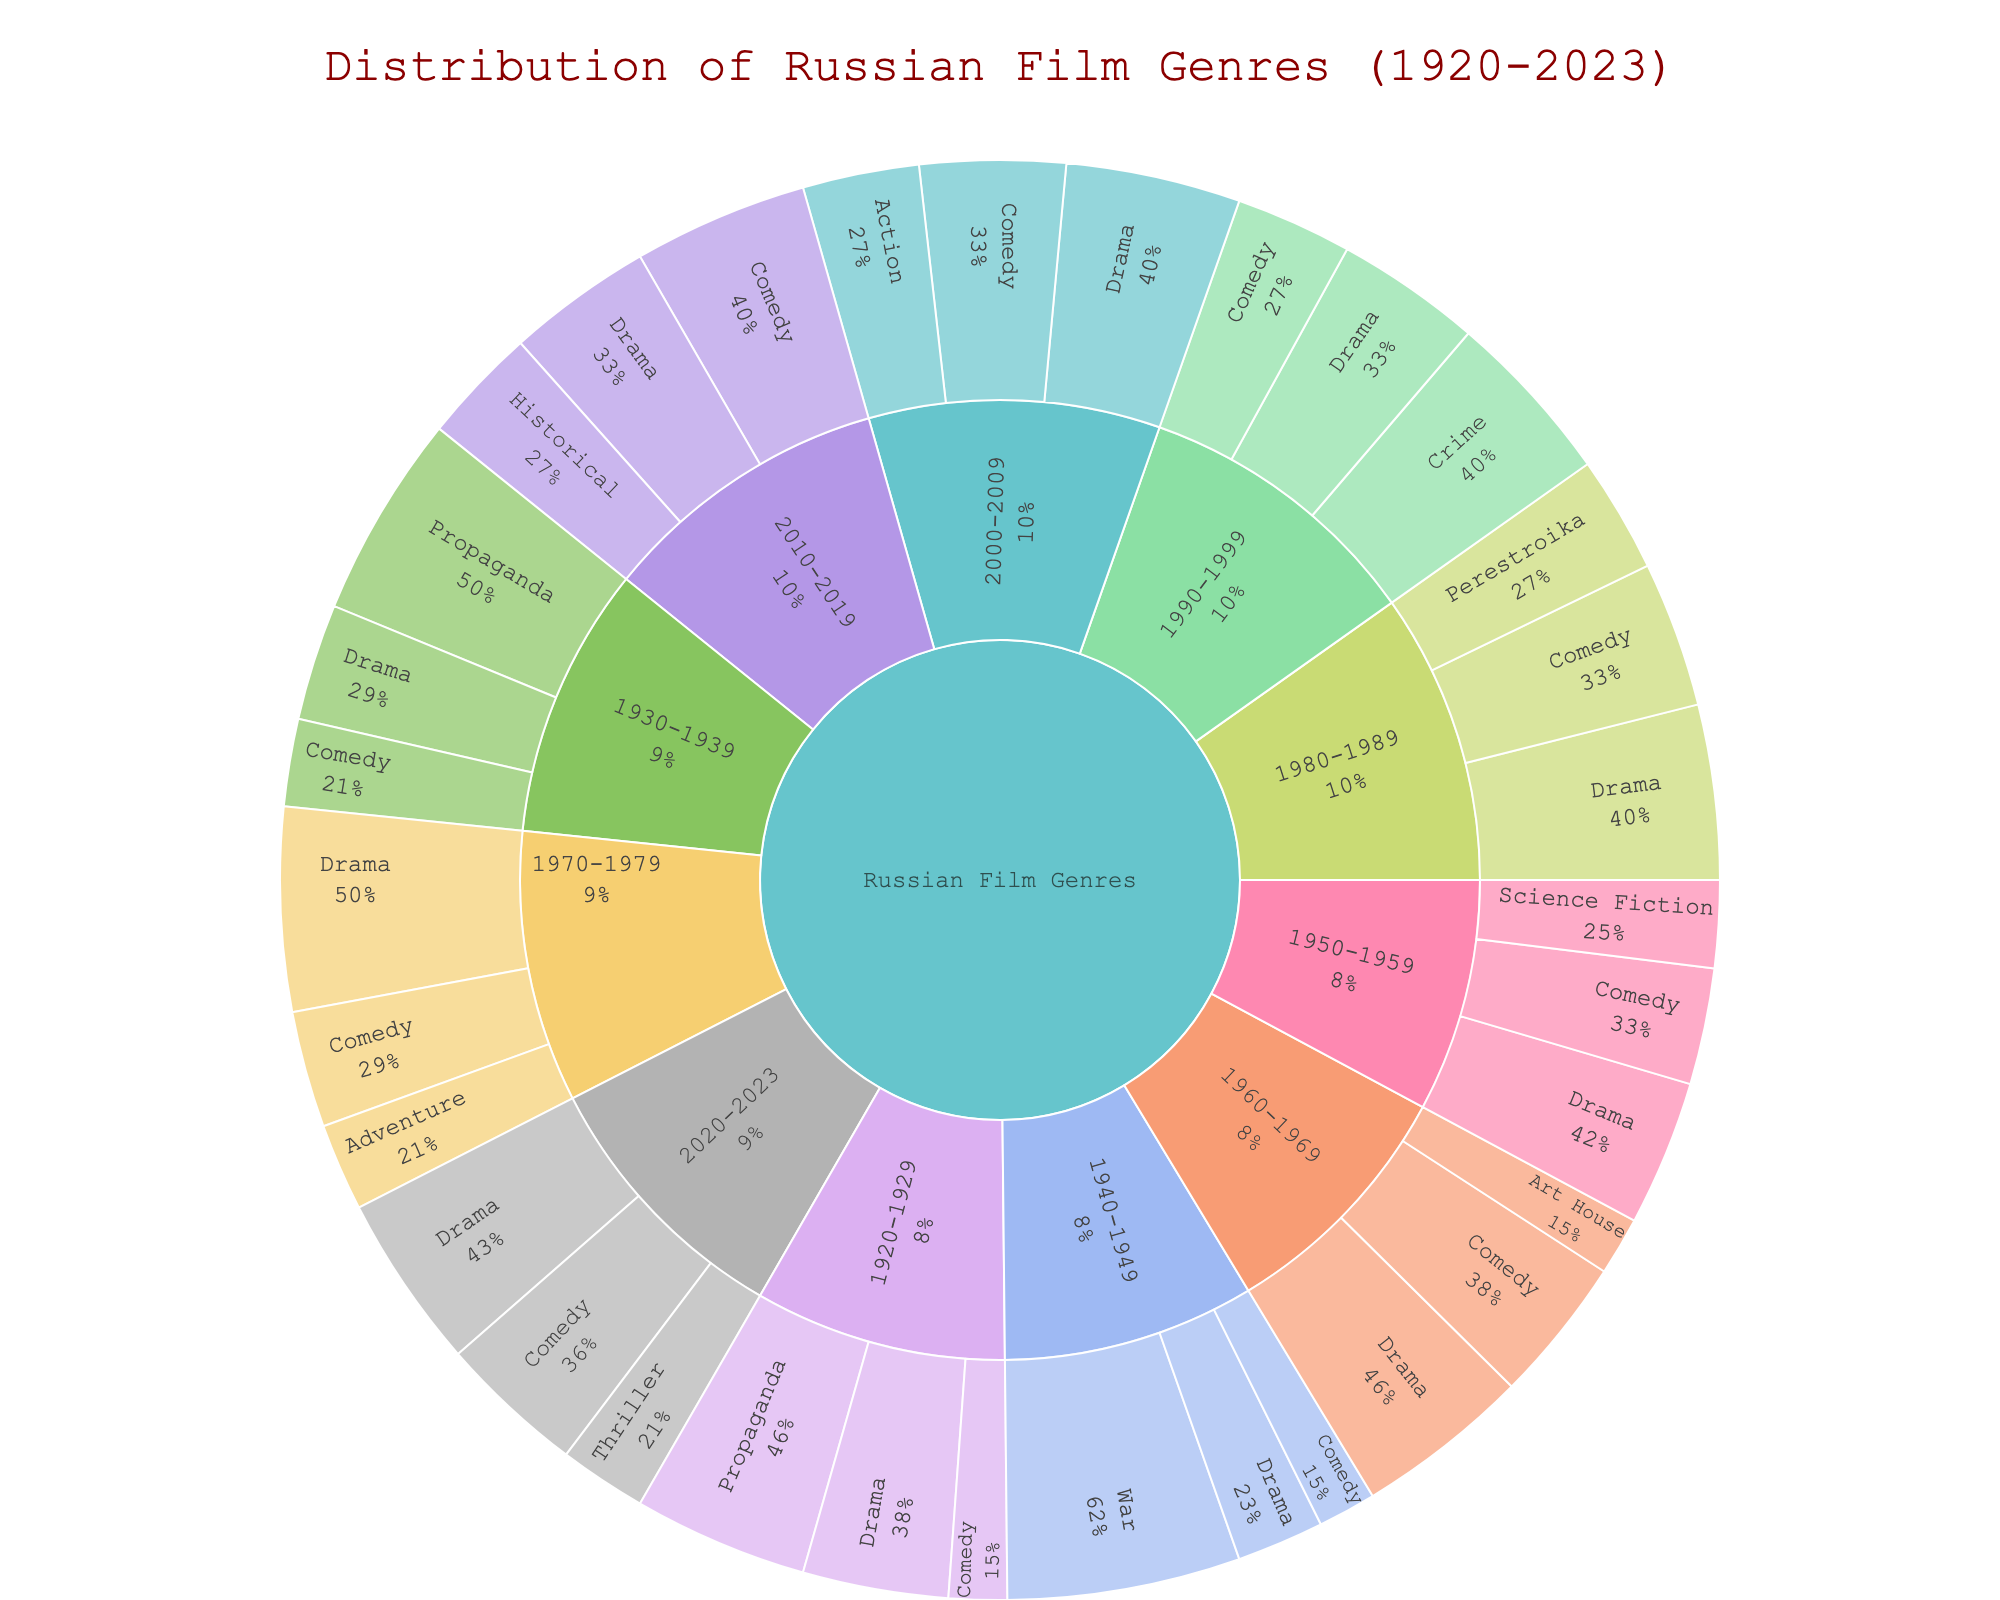What's the title of the figure? The title is typically found at the top of the figure and is clearly identifiable as it distinguishes the overall subject of the visualization.
Answer: Distribution of Russian Film Genres (1920-2023) Which genre has the highest representation in the 1940s? Look for the segment within the 1940s category and identify the genre with the largest value.
Answer: War How many sub-genres are there in the 1980s? Count all the sub-genres listed under the 1980s decade category.
Answer: 3 In which decade does the 'Adventure' genre appear? Scan through each decade’s categories to locate the 'Adventure' genre.
Answer: 1970-1979 What is the combined value of Comedy in the 1990s and 2000s? Identify the Comedy values for 1990-1999 and 2000-2009 and sum them up: 20 + 25.
Answer: 45 Which decade has the highest total representation of films? Sum the values of all sub-genres for each decade and compare to find the highest total.
Answer: 1940-1949 How many genres are represented in the 2020s? Count distinct genres under the 2020-2023 decade category.
Answer: 3 Compare the representation of Drama in the 1920s and the 2020s. Which decade has more? Check the values for Drama in both decades and compare: 25 (1920s) vs 30 (2020s).
Answer: 2020s Calculate the total representation of Propaganda genre across all decades. Sum the values of Propaganda genre across all its occurrences: 30 (1920s) + 35 (1930s).
Answer: 65 Which subcategory has the highest value within the 1960-1969 category? Find the subcategory with the largest value within the 1960-1969 category.
Answer: Drama 